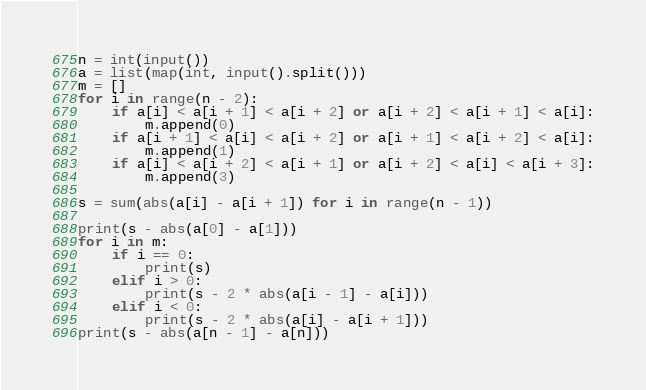Convert code to text. <code><loc_0><loc_0><loc_500><loc_500><_Python_>n = int(input())
a = list(map(int, input().split()))
m = []
for i in range(n - 2):
    if a[i] < a[i + 1] < a[i + 2] or a[i + 2] < a[i + 1] < a[i]:
        m.append(0)
    if a[i + 1] < a[i] < a[i + 2] or a[i + 1] < a[i + 2] < a[i]:
        m.append(1)
    if a[i] < a[i + 2] < a[i + 1] or a[i + 2] < a[i] < a[i + 3]:
        m.append(3)

s = sum(abs(a[i] - a[i + 1]) for i in range(n - 1))

print(s - abs(a[0] - a[1]))
for i in m:
    if i == 0:
        print(s)
    elif i > 0:
        print(s - 2 * abs(a[i - 1] - a[i]))
    elif i < 0:
        print(s - 2 * abs(a[i] - a[i + 1]))
print(s - abs(a[n - 1] - a[n]))
</code> 